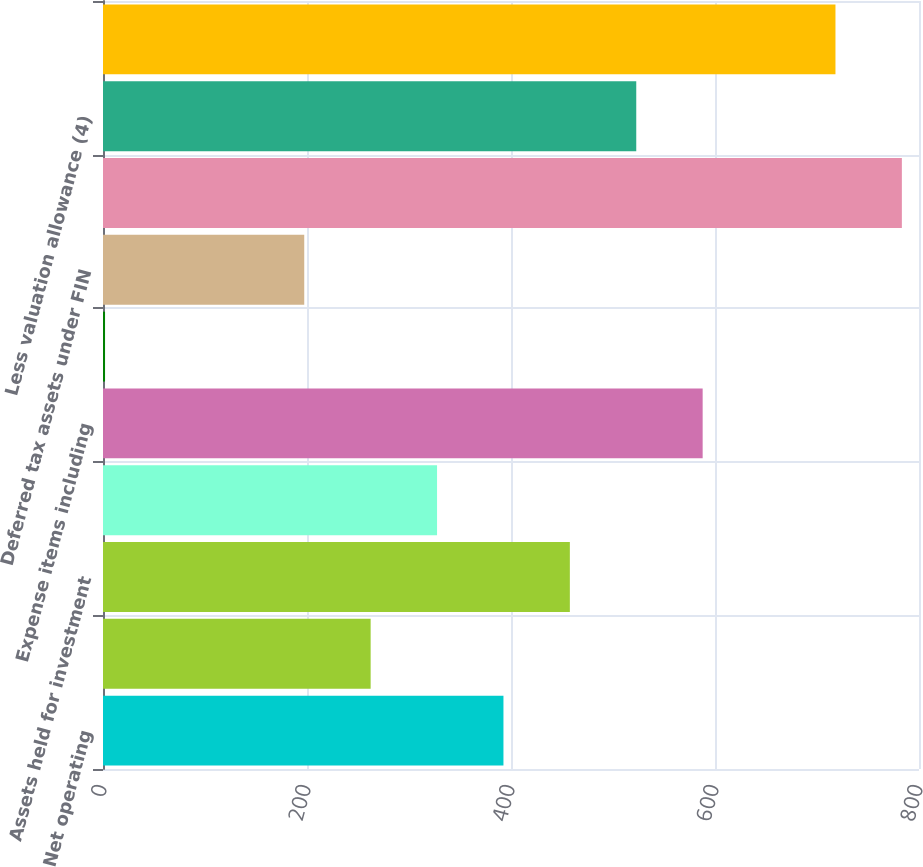<chart> <loc_0><loc_0><loc_500><loc_500><bar_chart><fcel>Net operating<fcel>Net operating losses-other<fcel>Assets held for investment<fcel>Revenue items<fcel>Expense items including<fcel>Net tax credits (3)<fcel>Deferred tax assets under FIN<fcel>Total gross deferred tax<fcel>Less valuation allowance (4)<fcel>Deferred tax assets net of<nl><fcel>392.6<fcel>262.4<fcel>457.7<fcel>327.5<fcel>587.9<fcel>2<fcel>197.3<fcel>783.2<fcel>522.8<fcel>718.1<nl></chart> 